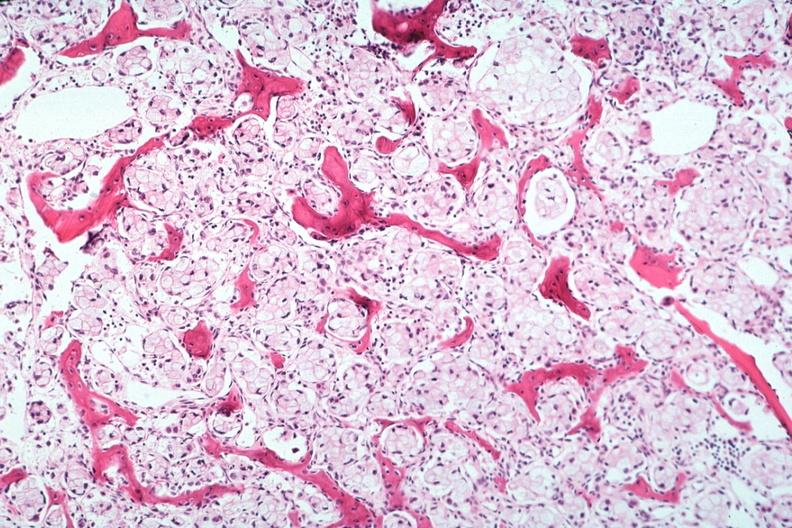what is present?
Answer the question using a single word or phrase. Joints 